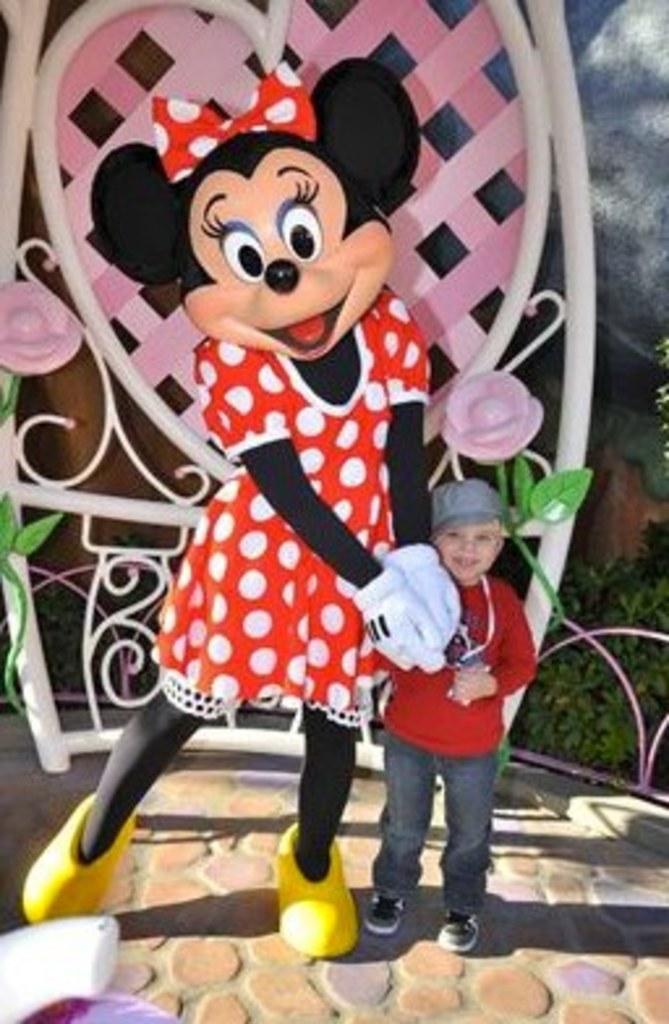Could you give a brief overview of what you see in this image? In this image I can see a boy standing beside the mickey mouse mannequin, backside of them there is a colorful fence and there are some plants visible on the right side. 